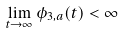<formula> <loc_0><loc_0><loc_500><loc_500>\lim _ { t \to \infty } \phi _ { 3 , a } ( t ) < \infty</formula> 